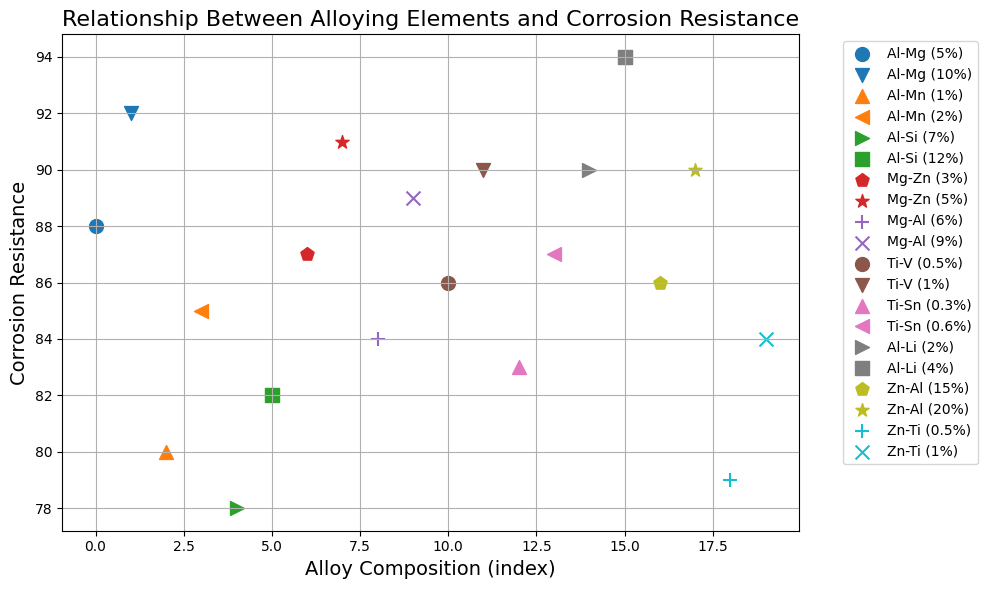What's the average corrosion resistance of the Al-based alloys? From the plot, identify all the Al-based alloys, which include Al-Mg (5%), Al-Mg (10%), Al-Mn (1%), Al-Mn (2%), Al-Si (7%), Al-Si (12%), and Al-Li (2%), Al-Li (4%). Their respective corrosion resistance values are 88, 92, 80, 85, 78, 82, 90, and 94. Sum these values: 88 + 92 + 80 + 85 + 78 + 82 + 90 + 94 = 689. The count of Al-based alloys is 8. Therefore, average = 689/8 = 86.125
Answer: 86.125 Which alloy composition has the highest corrosion resistance? Scan the plot to find the highest point on the y-axis, representing the maximum corrosion resistance. The highest value is 94, which corresponds to the alloy composition Al-Li (4%).
Answer: Al-Li (4%) Between Mg-Al (6%) and Mg-Al (9%), which one shows higher corrosion resistance and by how much? From the plot, identify the corrosion resistance values for Mg-Al (6%) and Mg-Al (9%), which are 84 and 89, respectively. The difference is calculated as 89 - 84 = 5. Thus, Mg-Al (9%) has a higher corrosion resistance by 5 units.
Answer: Mg-Al (9%) by 5 Which alloy composition has the lowest corrosion resistance? Scan the plot to find the lowest point on the y-axis, representing the minimum corrosion resistance. The lowest value is 78, which corresponds to the alloy composition Al-Si (7%).
Answer: Al-Si (7%) What is the median corrosion resistance of the alloys? To find the median, list all the corrosion resistance values: 78, 79, 80, 82, 83, 84, 85, 86, 86, 87, 87, 88, 89, 90, 90, 91, 92, 94. Since there are 18 values, the median will be the average of the 9th and 10th values. The 9th and 10th values are 86 and 87. Therefore, median = (86 + 87) / 2 = 86.5
Answer: 86.5 Which has a more variable corrosion resistance, Al-based or Ti-based alloys? First, identify the corrosion resistance values for Al-based alloys (88, 92, 80, 85, 78, 82, 90, 94) and Ti-based alloys (86, 90, 83, 87). Calculate the range for each group. For Al-based: range = 94 - 78 = 16. For Ti-based: range = 90 - 83 = 7. Therefore, Al-based alloys have a more variable corrosion resistance.
Answer: Al-based alloys Among Zn-Al (15%) and Zn-Al (20%), which one exhibits higher corrosion resistance? From the plot, find the corrosion resistance values for Zn-Al (15%) and Zn-Al (20%), which are 86 and 90, respectively. Zn-Al (20%) has a higher corrosion resistance.
Answer: Zn-Al (20%) What is the difference in corrosion resistance between the highest and lowest alloy compositions? Identify the highest and lowest corrosion resistance values from the plot, which are 94 (Al-Li (4%)) and 78 (Al-Si (7%)), respectively. The difference is calculated as 94 - 78 = 16.
Answer: 16 